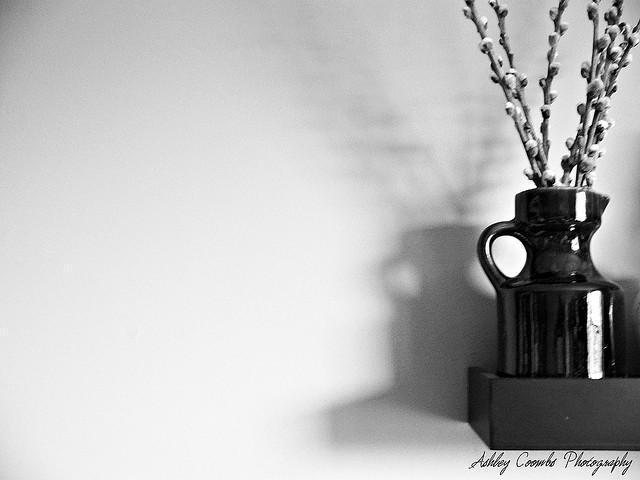How many flower sticks are there in the pot?
Give a very brief answer. 6. How many vases are there?
Give a very brief answer. 1. How many pieces of paper is the man with blue jeans holding?
Give a very brief answer. 0. 